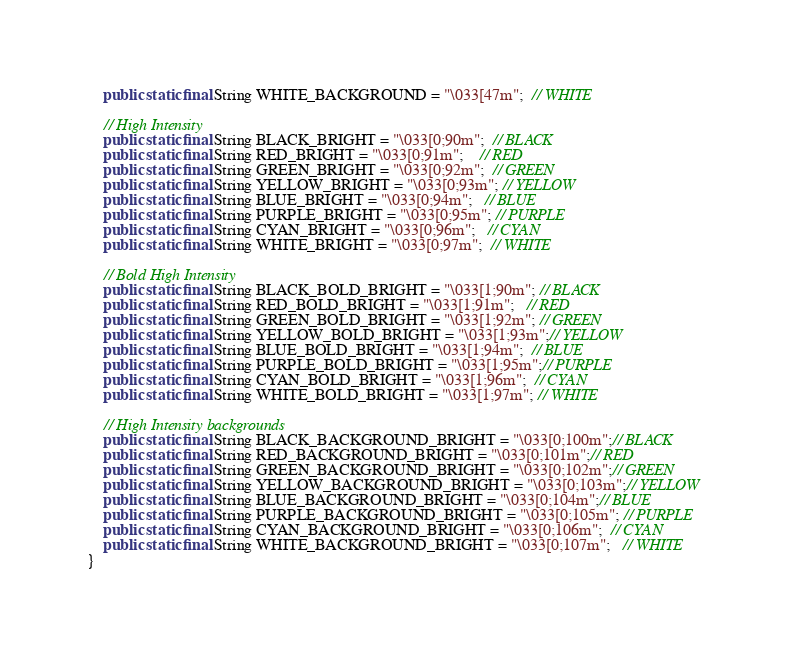Convert code to text. <code><loc_0><loc_0><loc_500><loc_500><_Java_>    public static final String WHITE_BACKGROUND = "\033[47m";  // WHITE

    // High Intensity
    public static final String BLACK_BRIGHT = "\033[0;90m";  // BLACK
    public static final String RED_BRIGHT = "\033[0;91m";    // RED
    public static final String GREEN_BRIGHT = "\033[0;92m";  // GREEN
    public static final String YELLOW_BRIGHT = "\033[0;93m"; // YELLOW
    public static final String BLUE_BRIGHT = "\033[0;94m";   // BLUE
    public static final String PURPLE_BRIGHT = "\033[0;95m"; // PURPLE
    public static final String CYAN_BRIGHT = "\033[0;96m";   // CYAN
    public static final String WHITE_BRIGHT = "\033[0;97m";  // WHITE

    // Bold High Intensity
    public static final String BLACK_BOLD_BRIGHT = "\033[1;90m"; // BLACK
    public static final String RED_BOLD_BRIGHT = "\033[1;91m";   // RED
    public static final String GREEN_BOLD_BRIGHT = "\033[1;92m"; // GREEN
    public static final String YELLOW_BOLD_BRIGHT = "\033[1;93m";// YELLOW
    public static final String BLUE_BOLD_BRIGHT = "\033[1;94m";  // BLUE
    public static final String PURPLE_BOLD_BRIGHT = "\033[1;95m";// PURPLE
    public static final String CYAN_BOLD_BRIGHT = "\033[1;96m";  // CYAN
    public static final String WHITE_BOLD_BRIGHT = "\033[1;97m"; // WHITE

    // High Intensity backgrounds
    public static final String BLACK_BACKGROUND_BRIGHT = "\033[0;100m";// BLACK
    public static final String RED_BACKGROUND_BRIGHT = "\033[0;101m";// RED
    public static final String GREEN_BACKGROUND_BRIGHT = "\033[0;102m";// GREEN
    public static final String YELLOW_BACKGROUND_BRIGHT = "\033[0;103m";// YELLOW
    public static final String BLUE_BACKGROUND_BRIGHT = "\033[0;104m";// BLUE
    public static final String PURPLE_BACKGROUND_BRIGHT = "\033[0;105m"; // PURPLE
    public static final String CYAN_BACKGROUND_BRIGHT = "\033[0;106m";  // CYAN
    public static final String WHITE_BACKGROUND_BRIGHT = "\033[0;107m";   // WHITE
}</code> 